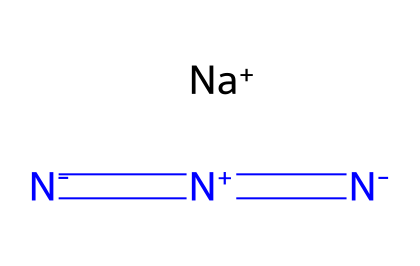What is the main ionic component present in sodium azide? The structure includes a sodium ion (Na+) indicated by the symbol in the SMILES representation, which clearly shows that sodium azide is an ionic compound.
Answer: sodium How many nitrogen atoms are present in sodium azide? By analyzing the SMILES, there are three nitrogen atoms represented by the multiple nitrogen symbols (N) in the formula, confirming their presence.
Answer: three What is the overall charge of the azide ion present in sodium azide? The azide group has a structure of [N-]=[N+]=[N-], indicating that it has a net charge of -1, due to the charge balance within the group.
Answer: -1 Which functional group characterizes sodium azide? The presence of the azide group represented by -N3 is a defining feature of sodium azide, differentiating it from other nitrogen compounds.
Answer: azide What type of bond is found between the nitrogen atoms in sodium azide? The nitrogen atoms in the azide part ([N-]=[N+]=[N-]) are connected by a combination of single and double bonds, highlighting the unique bonding in azides.
Answer: mixed What is a major application of sodium azide in technology? Sodium azide is primarily used in airbag deployment systems, where its rapid decomposition produces gas, which is essential for airbag inflation.
Answer: airbag 